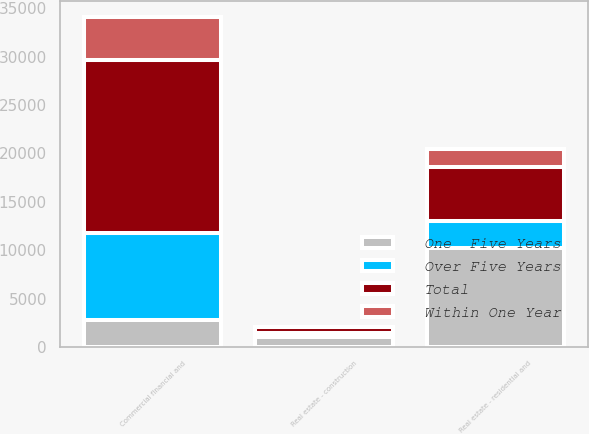Convert chart to OTSL. <chart><loc_0><loc_0><loc_500><loc_500><stacked_bar_chart><ecel><fcel>Commercial financial and<fcel>Real estate - construction<fcel>Real estate - residential and<nl><fcel>Over Five Years<fcel>8942<fcel>432<fcel>2838<nl><fcel>Total<fcel>17845<fcel>596<fcel>5549<nl><fcel>Within One Year<fcel>4453<fcel>25<fcel>1814<nl><fcel>One  Five Years<fcel>2838<fcel>1053<fcel>10201<nl></chart> 